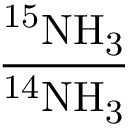<formula> <loc_0><loc_0><loc_500><loc_500>\frac { ^ { 1 5 } N H _ { 3 } } { ^ { 1 4 } N H _ { 3 } }</formula> 